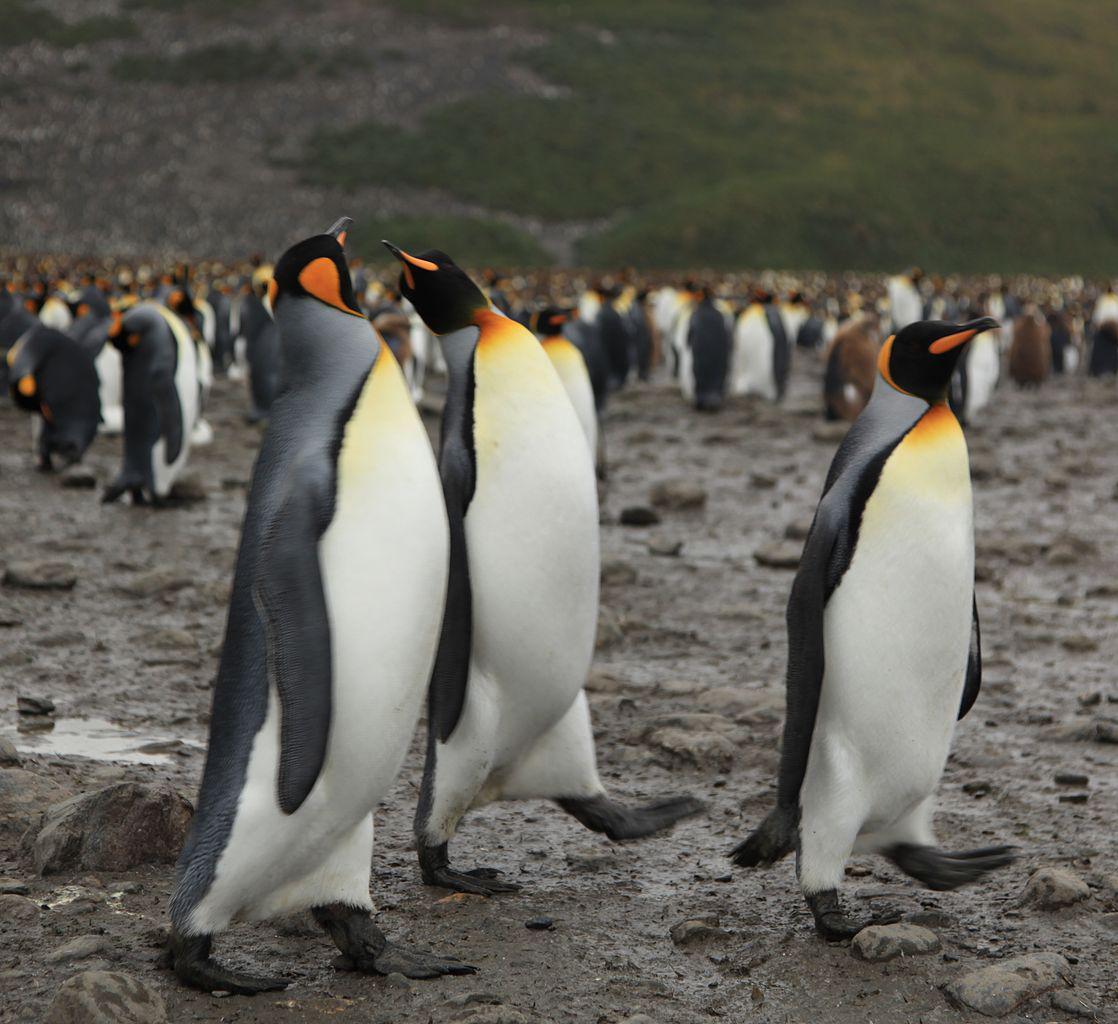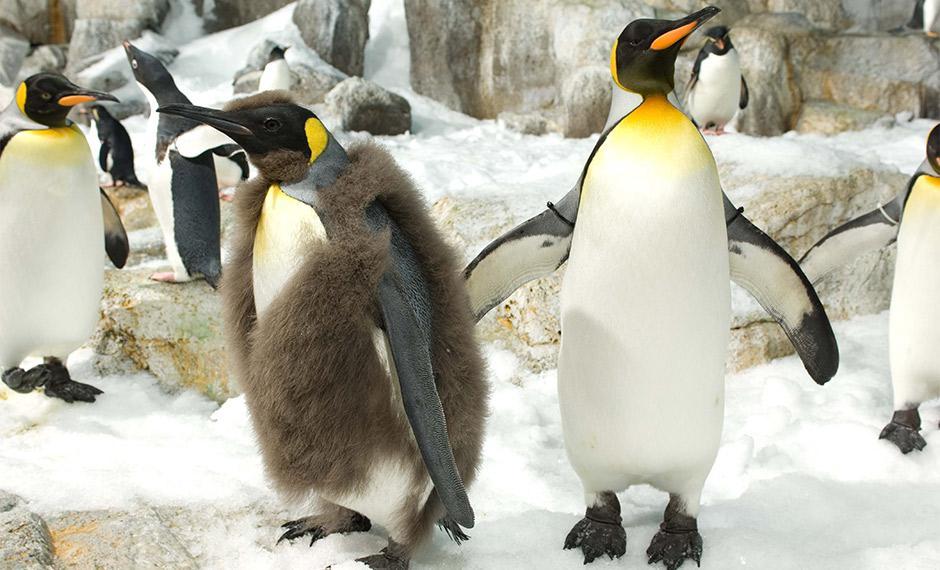The first image is the image on the left, the second image is the image on the right. Assess this claim about the two images: "There are penguins standing on snow.". Correct or not? Answer yes or no. Yes. The first image is the image on the left, the second image is the image on the right. Given the left and right images, does the statement "In one image, the foreground includes at least one penguin fully covered in fuzzy brown." hold true? Answer yes or no. No. 